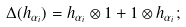Convert formula to latex. <formula><loc_0><loc_0><loc_500><loc_500>\Delta ( h _ { \alpha _ { i } } ) = h _ { \alpha _ { i } } \otimes 1 + 1 \otimes h _ { \alpha _ { i } } ;</formula> 